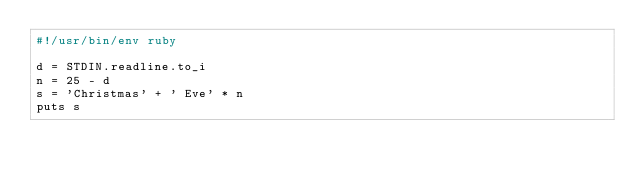<code> <loc_0><loc_0><loc_500><loc_500><_Ruby_>#!/usr/bin/env ruby

d = STDIN.readline.to_i
n = 25 - d 
s = 'Christmas' + ' Eve' * n
puts s
</code> 